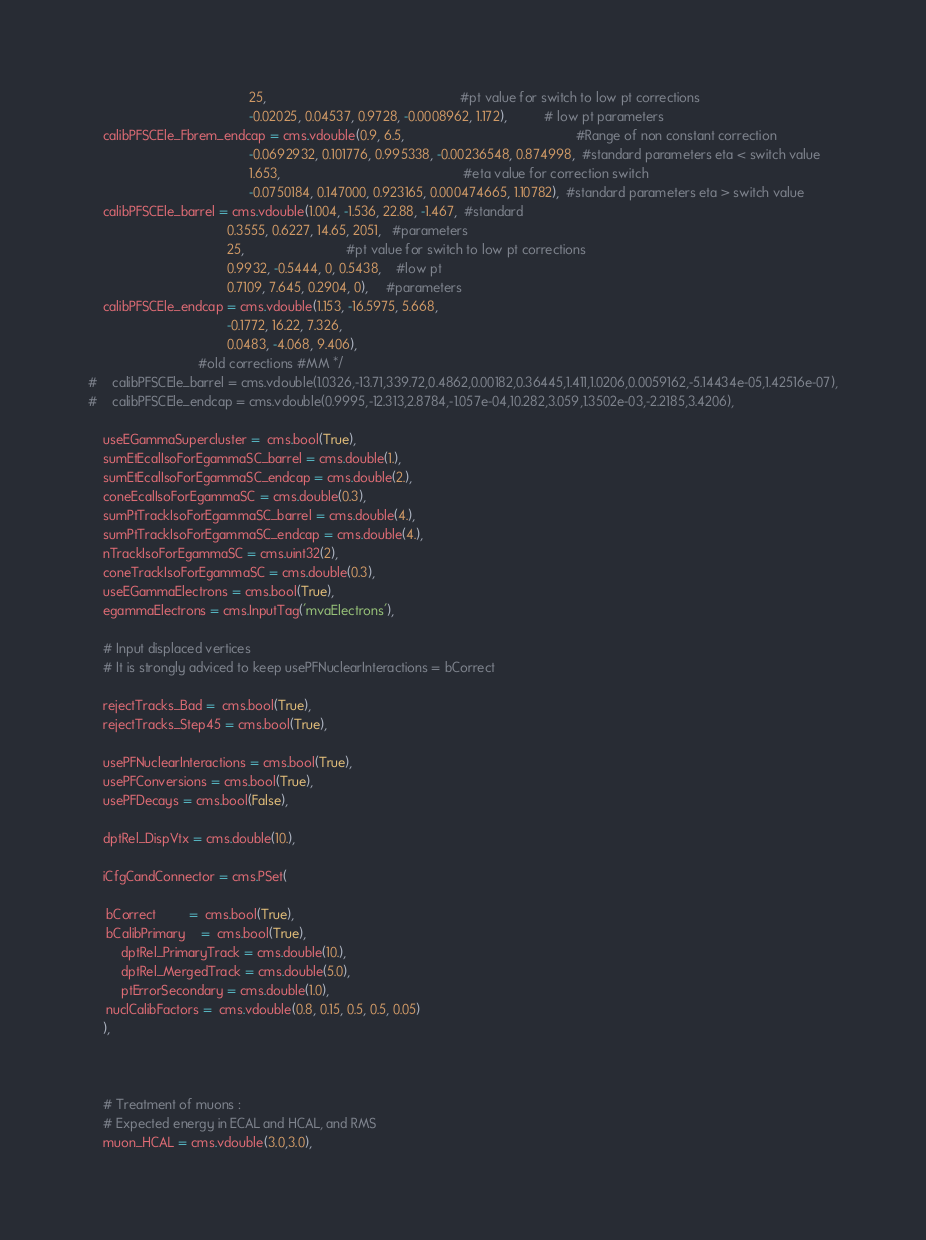Convert code to text. <code><loc_0><loc_0><loc_500><loc_500><_Python_>                                            25,                                                     #pt value for switch to low pt corrections
                                            -0.02025, 0.04537, 0.9728, -0.0008962, 1.172),          # low pt parameters
    calibPFSCEle_Fbrem_endcap = cms.vdouble(0.9, 6.5,                                               #Range of non constant correction
                                            -0.0692932, 0.101776, 0.995338, -0.00236548, 0.874998,  #standard parameters eta < switch value
                                            1.653,                                                  #eta value for correction switch
                                            -0.0750184, 0.147000, 0.923165, 0.000474665, 1.10782),  #standard parameters eta > switch value
    calibPFSCEle_barrel = cms.vdouble(1.004, -1.536, 22.88, -1.467,  #standard
                                      0.3555, 0.6227, 14.65, 2051,   #parameters
                                      25,                            #pt value for switch to low pt corrections
                                      0.9932, -0.5444, 0, 0.5438,    #low pt
                                      0.7109, 7.645, 0.2904, 0),     #parameters
    calibPFSCEle_endcap = cms.vdouble(1.153, -16.5975, 5.668,
                                      -0.1772, 16.22, 7.326,
                                      0.0483, -4.068, 9.406),
                              #old corrections #MM */
#    calibPFSCEle_barrel = cms.vdouble(1.0326,-13.71,339.72,0.4862,0.00182,0.36445,1.411,1.0206,0.0059162,-5.14434e-05,1.42516e-07),
#    calibPFSCEle_endcap = cms.vdouble(0.9995,-12.313,2.8784,-1.057e-04,10.282,3.059,1.3502e-03,-2.2185,3.4206),

    useEGammaSupercluster =  cms.bool(True),
    sumEtEcalIsoForEgammaSC_barrel = cms.double(1.),
    sumEtEcalIsoForEgammaSC_endcap = cms.double(2.),
    coneEcalIsoForEgammaSC = cms.double(0.3),
    sumPtTrackIsoForEgammaSC_barrel = cms.double(4.),
    sumPtTrackIsoForEgammaSC_endcap = cms.double(4.),
    nTrackIsoForEgammaSC = cms.uint32(2),                          
    coneTrackIsoForEgammaSC = cms.double(0.3),
    useEGammaElectrons = cms.bool(True),                                 
    egammaElectrons = cms.InputTag('mvaElectrons'),                              

    # Input displaced vertices
    # It is strongly adviced to keep usePFNuclearInteractions = bCorrect                       
                              
    rejectTracks_Bad =  cms.bool(True),
    rejectTracks_Step45 = cms.bool(True),

    usePFNuclearInteractions = cms.bool(True),
    usePFConversions = cms.bool(True),
    usePFDecays = cms.bool(False),

    dptRel_DispVtx = cms.double(10.),

    iCfgCandConnector = cms.PSet(
    
	 bCorrect         =  cms.bool(True), 
	 bCalibPrimary    =  cms.bool(True),
         dptRel_PrimaryTrack = cms.double(10.),
         dptRel_MergedTrack = cms.double(5.0),
         ptErrorSecondary = cms.double(1.0),
	 nuclCalibFactors =  cms.vdouble(0.8, 0.15, 0.5, 0.5, 0.05)
    ),

    

    # Treatment of muons : 
    # Expected energy in ECAL and HCAL, and RMS
    muon_HCAL = cms.vdouble(3.0,3.0),</code> 